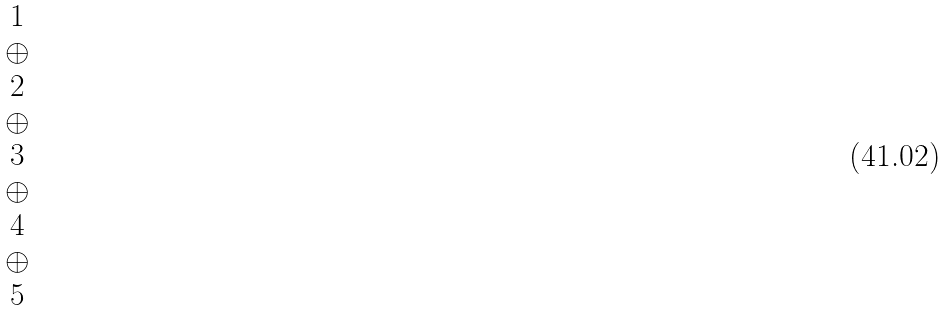Convert formula to latex. <formula><loc_0><loc_0><loc_500><loc_500>\begin{matrix} 1 \\ \oplus \\ 2 \\ \oplus \\ 3 \\ \oplus \\ 4 \\ \oplus \\ 5 \end{matrix}</formula> 